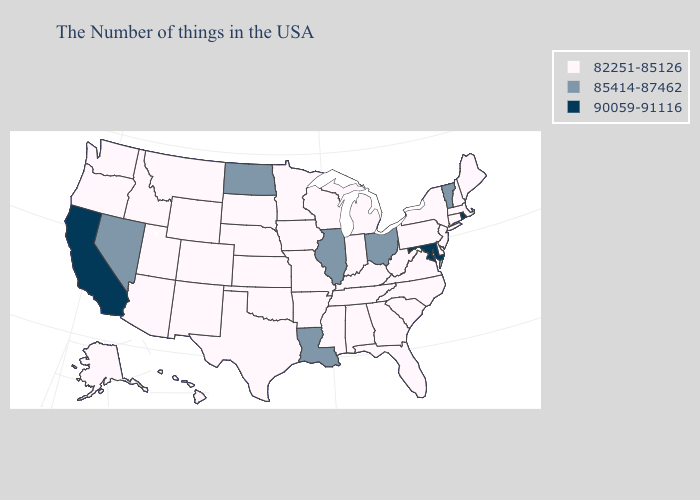Name the states that have a value in the range 90059-91116?
Short answer required. Rhode Island, Maryland, California. Among the states that border Iowa , does Minnesota have the lowest value?
Be succinct. Yes. Name the states that have a value in the range 90059-91116?
Answer briefly. Rhode Island, Maryland, California. Among the states that border Utah , does Wyoming have the highest value?
Give a very brief answer. No. Among the states that border Massachusetts , which have the lowest value?
Keep it brief. New Hampshire, Connecticut, New York. What is the highest value in the MidWest ?
Quick response, please. 85414-87462. Name the states that have a value in the range 85414-87462?
Write a very short answer. Vermont, Ohio, Illinois, Louisiana, North Dakota, Nevada. Which states have the lowest value in the West?
Write a very short answer. Wyoming, Colorado, New Mexico, Utah, Montana, Arizona, Idaho, Washington, Oregon, Alaska, Hawaii. Does the first symbol in the legend represent the smallest category?
Keep it brief. Yes. Does California have the lowest value in the West?
Short answer required. No. What is the value of Michigan?
Answer briefly. 82251-85126. Does Louisiana have the highest value in the South?
Keep it brief. No. Name the states that have a value in the range 85414-87462?
Concise answer only. Vermont, Ohio, Illinois, Louisiana, North Dakota, Nevada. What is the value of Washington?
Quick response, please. 82251-85126. Does Texas have the same value as Nebraska?
Quick response, please. Yes. 